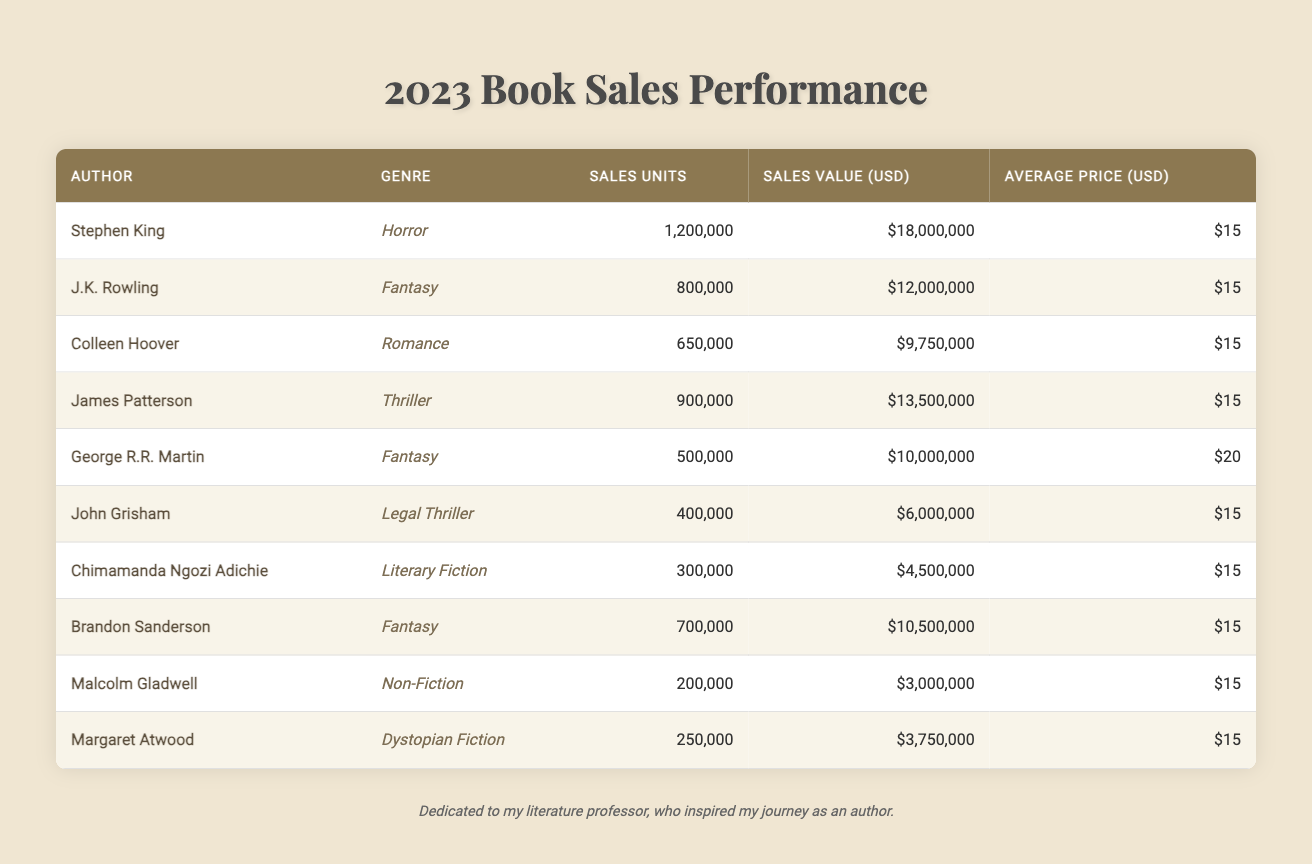What's the total sales units for all authors in the table? To find the total sales units, sum the sales units of each author listed: 1,200,000 + 800,000 + 650,000 + 900,000 + 500,000 + 400,000 + 300,000 + 700,000 + 200,000 + 250,000 = 5,650,000.
Answer: 5,650,000 Which author has the highest sales value? The author with the highest sales value can be found by comparing the sales values of each author. Stephen King has a sales value of $18,000,000, which is greater than all the others.
Answer: Stephen King What is the average price of books sold across all genres? The average price is consistent at $15 for the majority, with George R.R. Martin's books priced at $20. However, since the average is taken based on the number of sales units, the overall average price remains $15 due to the number of units sold.
Answer: $15 What percentage of the total sales units does J.K. Rowling represent? First, find J.K. Rowling's sales units which are 800,000. Then use the total sales units (5,650,000) to calculate the percentage: (800,000 / 5,650,000) * 100 = approximately 14.1%.
Answer: 14.1% Did any author sell more than 1 million units? Check the sales units for each author; Stephen King is the only one who sold over 1 million units (1,200,000).
Answer: Yes What genre had the lowest sales value? To find the genre with the lowest sales value, compare the sales values: Dystopian Fiction (Margaret Atwood) sold for $3,750,000, which is the lowest.
Answer: Dystopian Fiction Which two genres together accounted for more than 2 million sales units? Summing the sales units of Fantasy (1,500,000 from Rowling, George R.R. Martin, and Sanderson) and Horror (1,200,000 from Stephen King) results in 2,700,000 units, which exceeds 2 million.
Answer: Fantasy and Horror If you combine the sales value of Colleen Hoover and John Grisham, how much do they total? The sales value of Colleen Hoover is $9,750,000 and John Grisham is $6,000,000. Summing these gives $9,750,000 + $6,000,000 = $15,750,000.
Answer: $15,750,000 Which author has the lowest average price per book? The average price for each author is given, with all but George R.R. Martin priced at $15. He has the highest at $20, so the lowest average price per book is therefore $15.
Answer: $15 How many authors sold less than 500,000 units? Check the sales units: John Grisham (400,000), Chimamanda Ngozi Adichie (300,000), Malcolm Gladwell (200,000), and Margaret Atwood (250,000) add up to a total of four authors.
Answer: 4 